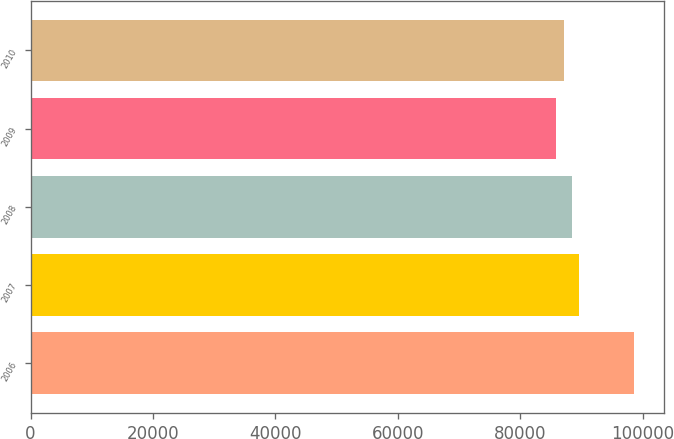<chart> <loc_0><loc_0><loc_500><loc_500><bar_chart><fcel>2006<fcel>2007<fcel>2008<fcel>2009<fcel>2010<nl><fcel>98520<fcel>89643.3<fcel>88375.2<fcel>85839<fcel>87107.1<nl></chart> 